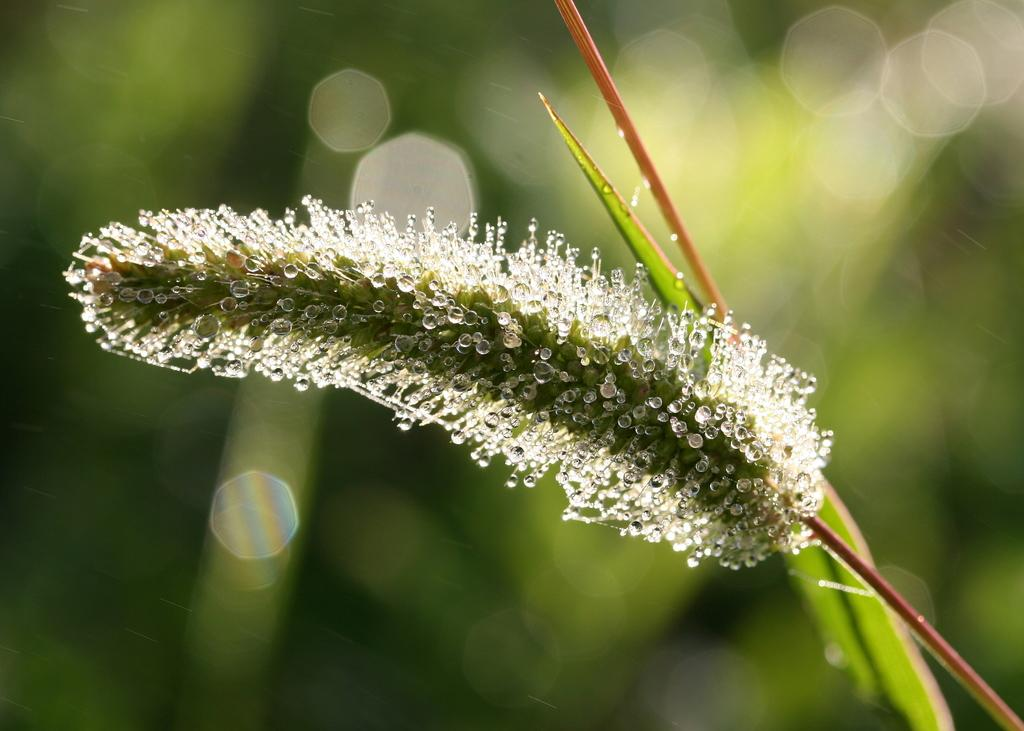What is present in the image? There is a plant in the image. Can you describe the background of the image? The background of the image is blurred. What type of coat is the crow wearing in the image? There is no crow or coat present in the image; it only features a plant and a blurred background. 